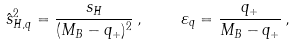Convert formula to latex. <formula><loc_0><loc_0><loc_500><loc_500>\hat { s } _ { H , q } ^ { 2 } = \frac { s _ { H } } { ( M _ { B } - q _ { + } ) ^ { 2 } } \, , \quad \varepsilon _ { q } = \frac { q _ { + } } { M _ { B } - q _ { + } } \, ,</formula> 